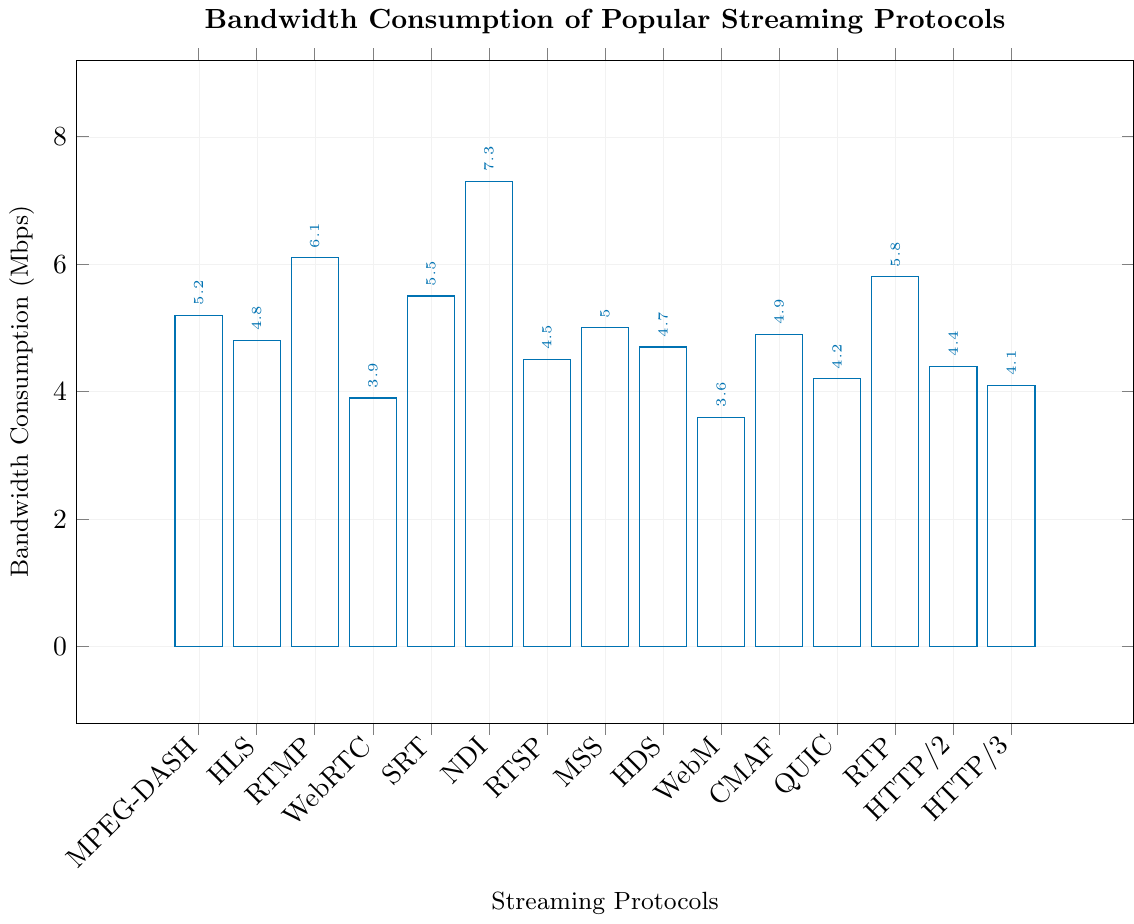Which streaming protocol has the highest bandwidth consumption? To find the highest bandwidth consumption, look for the tallest bar in the bar chart. The tallest bar corresponds to NDI, which has a bandwidth consumption of 7.3 Mbps.
Answer: NDI Which protocol consumes less bandwidth, HLS or RTSP? Compare the heights of the bars for HLS and RTSP. HLS has a bandwidth consumption of 4.8 Mbps, while RTSP has 4.5 Mbps. Therefore, RTSP consumes less bandwidth.
Answer: RTSP By how many Mbps does RTMP exceed WebM in terms of bandwidth consumption? To determine the difference, subtract WebM's bandwidth consumption from RTMP's. RTMP has 6.1 Mbps and WebM has 3.6 Mbps. The difference is 6.1 - 3.6 = 2.5 Mbps.
Answer: 2.5 Mbps What is the average bandwidth consumption of MPEG-DASH, HLS, and RTMP? To find the average, sum the bandwidth consumption values of MPEG-DASH (5.2 Mbps), HLS (4.8 Mbps), and RTMP (6.1 Mbps), then divide by 3. The total is 5.2 + 4.8 + 6.1 = 16.1, and the average is 16.1 / 3 = 5.37 Mbps.
Answer: 5.37 Mbps Which protocols have a bandwidth consumption higher than 5 Mbps? Identify the protocols with bandwidth consumption greater than 5 Mbps by looking at the bars whose height exceeds the 5 Mbps mark. These protocols are RTMP (6.1 Mbps), SRT (5.5 Mbps), NDI (7.3 Mbps), and RTP (5.8 Mbps).
Answer: RTMP, SRT, NDI, RTP What is the total bandwidth consumption of protocols that fall under HTTP-based streaming? Sum the bandwidth consumption values for HLS (4.8 Mbps), MSS (5.0 Mbps), HDS (4.7 Mbps), QUIC (4.2 Mbps), HTTP/2 (4.4 Mbps), and HTTP/3 (4.1 Mbps). The total is 4.8 + 5.0 + 4.7 + 4.2 + 4.4 + 4.1 = 27.2 Mbps.
Answer: 27.2 Mbps Which protocol consumes the lowest bandwidth? To find the lowest bandwidth consumption, locate the shortest bar in the bar chart. The shortest bar corresponds to WebM, which has a bandwidth consumption of 3.6 Mbps.
Answer: WebM How much more bandwidth does NDI consume compared to CMAF? Compare the bandwidth consumption of NDI (7.3 Mbps) and CMAF (4.9 Mbps). Subtract CMAF's consumption from NDI's. The difference is 7.3 - 4.9 = 2.4 Mbps.
Answer: 2.4 Mbps Which protocols have a similar bandwidth consumption around 4.5 Mbps? Look for bars with heights close to 4.5 Mbps. The protocols with similar bandwidth consumption are RTSP (4.5 Mbps), HTTP/2 (4.4 Mbps), and HDS (4.7 Mbps).
Answer: RTSP, HTTP/2, HDS 